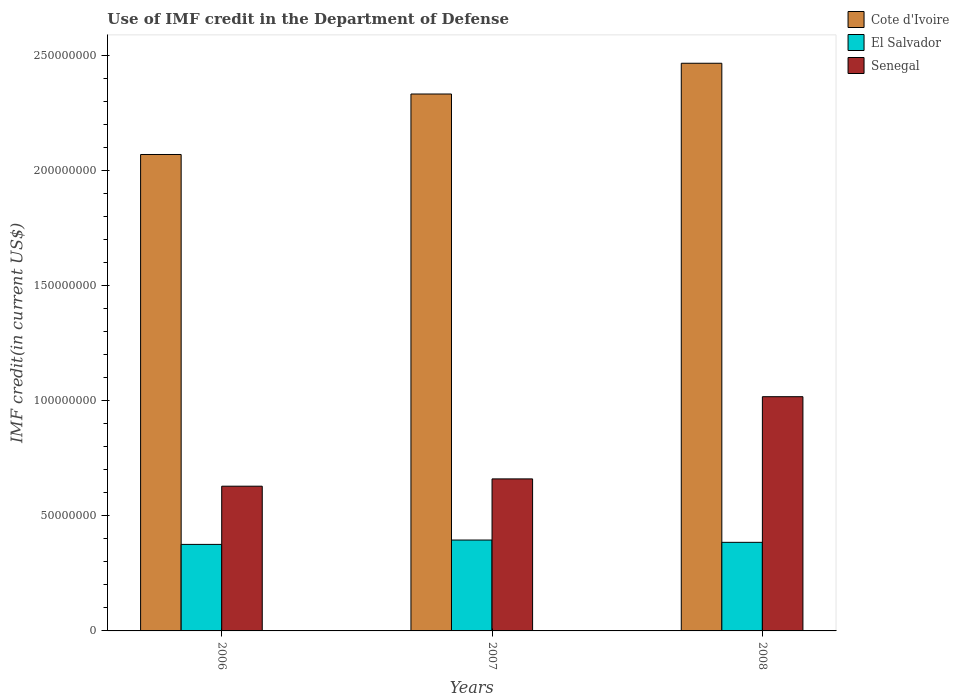How many groups of bars are there?
Your answer should be very brief. 3. Are the number of bars on each tick of the X-axis equal?
Provide a succinct answer. Yes. How many bars are there on the 1st tick from the left?
Offer a terse response. 3. What is the IMF credit in the Department of Defense in El Salvador in 2006?
Your answer should be compact. 3.76e+07. Across all years, what is the maximum IMF credit in the Department of Defense in Senegal?
Your response must be concise. 1.02e+08. Across all years, what is the minimum IMF credit in the Department of Defense in Senegal?
Offer a very short reply. 6.29e+07. What is the total IMF credit in the Department of Defense in Senegal in the graph?
Keep it short and to the point. 2.31e+08. What is the difference between the IMF credit in the Department of Defense in Cote d'Ivoire in 2006 and that in 2008?
Your response must be concise. -3.96e+07. What is the difference between the IMF credit in the Department of Defense in Cote d'Ivoire in 2008 and the IMF credit in the Department of Defense in Senegal in 2006?
Provide a short and direct response. 1.84e+08. What is the average IMF credit in the Department of Defense in Cote d'Ivoire per year?
Your answer should be very brief. 2.29e+08. In the year 2008, what is the difference between the IMF credit in the Department of Defense in El Salvador and IMF credit in the Department of Defense in Cote d'Ivoire?
Your answer should be very brief. -2.08e+08. What is the ratio of the IMF credit in the Department of Defense in Cote d'Ivoire in 2007 to that in 2008?
Provide a succinct answer. 0.95. Is the difference between the IMF credit in the Department of Defense in El Salvador in 2006 and 2007 greater than the difference between the IMF credit in the Department of Defense in Cote d'Ivoire in 2006 and 2007?
Your response must be concise. Yes. What is the difference between the highest and the second highest IMF credit in the Department of Defense in Senegal?
Provide a short and direct response. 3.57e+07. What is the difference between the highest and the lowest IMF credit in the Department of Defense in Senegal?
Your answer should be very brief. 3.89e+07. In how many years, is the IMF credit in the Department of Defense in El Salvador greater than the average IMF credit in the Department of Defense in El Salvador taken over all years?
Offer a terse response. 1. What does the 1st bar from the left in 2008 represents?
Make the answer very short. Cote d'Ivoire. What does the 2nd bar from the right in 2006 represents?
Your response must be concise. El Salvador. Is it the case that in every year, the sum of the IMF credit in the Department of Defense in El Salvador and IMF credit in the Department of Defense in Cote d'Ivoire is greater than the IMF credit in the Department of Defense in Senegal?
Give a very brief answer. Yes. Are all the bars in the graph horizontal?
Provide a succinct answer. No. What is the difference between two consecutive major ticks on the Y-axis?
Your answer should be compact. 5.00e+07. Are the values on the major ticks of Y-axis written in scientific E-notation?
Ensure brevity in your answer.  No. Does the graph contain any zero values?
Keep it short and to the point. No. Does the graph contain grids?
Your response must be concise. No. Where does the legend appear in the graph?
Your response must be concise. Top right. How are the legend labels stacked?
Your answer should be very brief. Vertical. What is the title of the graph?
Ensure brevity in your answer.  Use of IMF credit in the Department of Defense. Does "Central Europe" appear as one of the legend labels in the graph?
Ensure brevity in your answer.  No. What is the label or title of the Y-axis?
Make the answer very short. IMF credit(in current US$). What is the IMF credit(in current US$) in Cote d'Ivoire in 2006?
Make the answer very short. 2.07e+08. What is the IMF credit(in current US$) in El Salvador in 2006?
Your answer should be compact. 3.76e+07. What is the IMF credit(in current US$) in Senegal in 2006?
Make the answer very short. 6.29e+07. What is the IMF credit(in current US$) of Cote d'Ivoire in 2007?
Provide a short and direct response. 2.33e+08. What is the IMF credit(in current US$) of El Salvador in 2007?
Your response must be concise. 3.95e+07. What is the IMF credit(in current US$) of Senegal in 2007?
Offer a terse response. 6.60e+07. What is the IMF credit(in current US$) in Cote d'Ivoire in 2008?
Provide a short and direct response. 2.47e+08. What is the IMF credit(in current US$) in El Salvador in 2008?
Ensure brevity in your answer.  3.85e+07. What is the IMF credit(in current US$) in Senegal in 2008?
Your response must be concise. 1.02e+08. Across all years, what is the maximum IMF credit(in current US$) of Cote d'Ivoire?
Your response must be concise. 2.47e+08. Across all years, what is the maximum IMF credit(in current US$) of El Salvador?
Your answer should be compact. 3.95e+07. Across all years, what is the maximum IMF credit(in current US$) of Senegal?
Provide a short and direct response. 1.02e+08. Across all years, what is the minimum IMF credit(in current US$) of Cote d'Ivoire?
Your answer should be very brief. 2.07e+08. Across all years, what is the minimum IMF credit(in current US$) in El Salvador?
Keep it short and to the point. 3.76e+07. Across all years, what is the minimum IMF credit(in current US$) of Senegal?
Offer a terse response. 6.29e+07. What is the total IMF credit(in current US$) in Cote d'Ivoire in the graph?
Ensure brevity in your answer.  6.87e+08. What is the total IMF credit(in current US$) in El Salvador in the graph?
Your response must be concise. 1.16e+08. What is the total IMF credit(in current US$) in Senegal in the graph?
Your response must be concise. 2.31e+08. What is the difference between the IMF credit(in current US$) of Cote d'Ivoire in 2006 and that in 2007?
Give a very brief answer. -2.63e+07. What is the difference between the IMF credit(in current US$) in El Salvador in 2006 and that in 2007?
Offer a terse response. -1.90e+06. What is the difference between the IMF credit(in current US$) in Senegal in 2006 and that in 2007?
Provide a short and direct response. -3.17e+06. What is the difference between the IMF credit(in current US$) in Cote d'Ivoire in 2006 and that in 2008?
Your answer should be very brief. -3.96e+07. What is the difference between the IMF credit(in current US$) in El Salvador in 2006 and that in 2008?
Your response must be concise. -8.97e+05. What is the difference between the IMF credit(in current US$) in Senegal in 2006 and that in 2008?
Your answer should be very brief. -3.89e+07. What is the difference between the IMF credit(in current US$) in Cote d'Ivoire in 2007 and that in 2008?
Ensure brevity in your answer.  -1.34e+07. What is the difference between the IMF credit(in current US$) of El Salvador in 2007 and that in 2008?
Your answer should be compact. 9.99e+05. What is the difference between the IMF credit(in current US$) in Senegal in 2007 and that in 2008?
Offer a very short reply. -3.57e+07. What is the difference between the IMF credit(in current US$) of Cote d'Ivoire in 2006 and the IMF credit(in current US$) of El Salvador in 2007?
Keep it short and to the point. 1.67e+08. What is the difference between the IMF credit(in current US$) of Cote d'Ivoire in 2006 and the IMF credit(in current US$) of Senegal in 2007?
Ensure brevity in your answer.  1.41e+08. What is the difference between the IMF credit(in current US$) of El Salvador in 2006 and the IMF credit(in current US$) of Senegal in 2007?
Your response must be concise. -2.85e+07. What is the difference between the IMF credit(in current US$) in Cote d'Ivoire in 2006 and the IMF credit(in current US$) in El Salvador in 2008?
Keep it short and to the point. 1.68e+08. What is the difference between the IMF credit(in current US$) in Cote d'Ivoire in 2006 and the IMF credit(in current US$) in Senegal in 2008?
Offer a terse response. 1.05e+08. What is the difference between the IMF credit(in current US$) in El Salvador in 2006 and the IMF credit(in current US$) in Senegal in 2008?
Provide a succinct answer. -6.42e+07. What is the difference between the IMF credit(in current US$) of Cote d'Ivoire in 2007 and the IMF credit(in current US$) of El Salvador in 2008?
Your response must be concise. 1.95e+08. What is the difference between the IMF credit(in current US$) of Cote d'Ivoire in 2007 and the IMF credit(in current US$) of Senegal in 2008?
Your answer should be compact. 1.31e+08. What is the difference between the IMF credit(in current US$) of El Salvador in 2007 and the IMF credit(in current US$) of Senegal in 2008?
Make the answer very short. -6.23e+07. What is the average IMF credit(in current US$) of Cote d'Ivoire per year?
Your response must be concise. 2.29e+08. What is the average IMF credit(in current US$) of El Salvador per year?
Provide a succinct answer. 3.85e+07. What is the average IMF credit(in current US$) in Senegal per year?
Provide a short and direct response. 7.69e+07. In the year 2006, what is the difference between the IMF credit(in current US$) in Cote d'Ivoire and IMF credit(in current US$) in El Salvador?
Keep it short and to the point. 1.69e+08. In the year 2006, what is the difference between the IMF credit(in current US$) of Cote d'Ivoire and IMF credit(in current US$) of Senegal?
Your answer should be very brief. 1.44e+08. In the year 2006, what is the difference between the IMF credit(in current US$) in El Salvador and IMF credit(in current US$) in Senegal?
Your answer should be very brief. -2.53e+07. In the year 2007, what is the difference between the IMF credit(in current US$) in Cote d'Ivoire and IMF credit(in current US$) in El Salvador?
Make the answer very short. 1.94e+08. In the year 2007, what is the difference between the IMF credit(in current US$) in Cote d'Ivoire and IMF credit(in current US$) in Senegal?
Offer a very short reply. 1.67e+08. In the year 2007, what is the difference between the IMF credit(in current US$) in El Salvador and IMF credit(in current US$) in Senegal?
Make the answer very short. -2.66e+07. In the year 2008, what is the difference between the IMF credit(in current US$) of Cote d'Ivoire and IMF credit(in current US$) of El Salvador?
Your answer should be very brief. 2.08e+08. In the year 2008, what is the difference between the IMF credit(in current US$) of Cote d'Ivoire and IMF credit(in current US$) of Senegal?
Ensure brevity in your answer.  1.45e+08. In the year 2008, what is the difference between the IMF credit(in current US$) of El Salvador and IMF credit(in current US$) of Senegal?
Offer a terse response. -6.33e+07. What is the ratio of the IMF credit(in current US$) of Cote d'Ivoire in 2006 to that in 2007?
Your answer should be compact. 0.89. What is the ratio of the IMF credit(in current US$) in Cote d'Ivoire in 2006 to that in 2008?
Offer a very short reply. 0.84. What is the ratio of the IMF credit(in current US$) of El Salvador in 2006 to that in 2008?
Your response must be concise. 0.98. What is the ratio of the IMF credit(in current US$) in Senegal in 2006 to that in 2008?
Make the answer very short. 0.62. What is the ratio of the IMF credit(in current US$) in Cote d'Ivoire in 2007 to that in 2008?
Your response must be concise. 0.95. What is the ratio of the IMF credit(in current US$) of Senegal in 2007 to that in 2008?
Your answer should be very brief. 0.65. What is the difference between the highest and the second highest IMF credit(in current US$) of Cote d'Ivoire?
Make the answer very short. 1.34e+07. What is the difference between the highest and the second highest IMF credit(in current US$) in El Salvador?
Provide a succinct answer. 9.99e+05. What is the difference between the highest and the second highest IMF credit(in current US$) of Senegal?
Ensure brevity in your answer.  3.57e+07. What is the difference between the highest and the lowest IMF credit(in current US$) in Cote d'Ivoire?
Offer a very short reply. 3.96e+07. What is the difference between the highest and the lowest IMF credit(in current US$) in El Salvador?
Your answer should be very brief. 1.90e+06. What is the difference between the highest and the lowest IMF credit(in current US$) in Senegal?
Your answer should be very brief. 3.89e+07. 